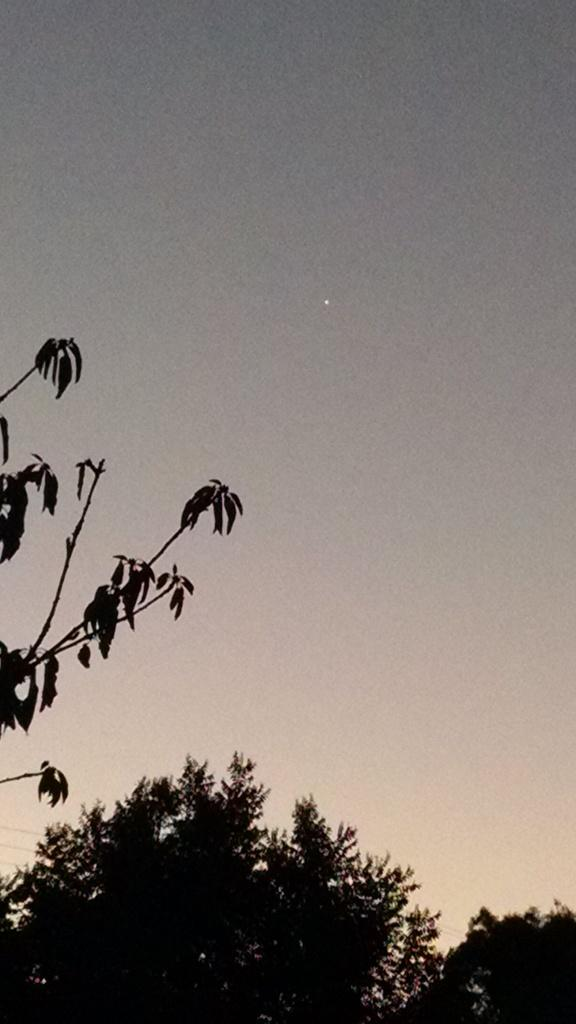What type of vegetation can be seen in the image? There are trees in the image. What part of the natural environment is visible in the image? The sky is visible in the image. How many owls can be seen in the image? There are no owls present in the image; it only features trees and the sky. 